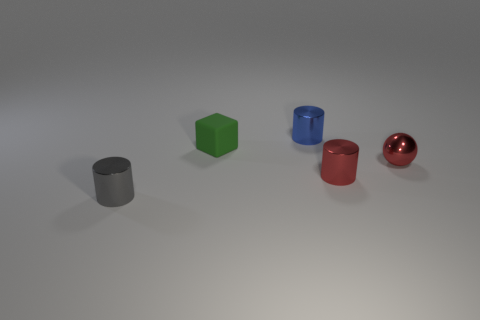Is the small rubber object the same color as the tiny sphere?
Provide a short and direct response. No. There is a small thing that is both in front of the metal ball and to the left of the tiny blue object; what is its color?
Your answer should be compact. Gray. There is a ball; are there any tiny red shiny things behind it?
Give a very brief answer. No. There is a small red object that is to the left of the red metal sphere; how many red metallic spheres are behind it?
Provide a short and direct response. 1. There is a blue object that is the same material as the gray object; what size is it?
Your answer should be very brief. Small. The rubber block has what size?
Your answer should be very brief. Small. Is the material of the tiny red cylinder the same as the tiny green thing?
Make the answer very short. No. What number of balls are blue objects or red rubber objects?
Give a very brief answer. 0. There is a metal cylinder to the right of the cylinder that is behind the green rubber object; what color is it?
Provide a succinct answer. Red. There is a metallic thing that is the same color as the shiny ball; what is its size?
Make the answer very short. Small. 